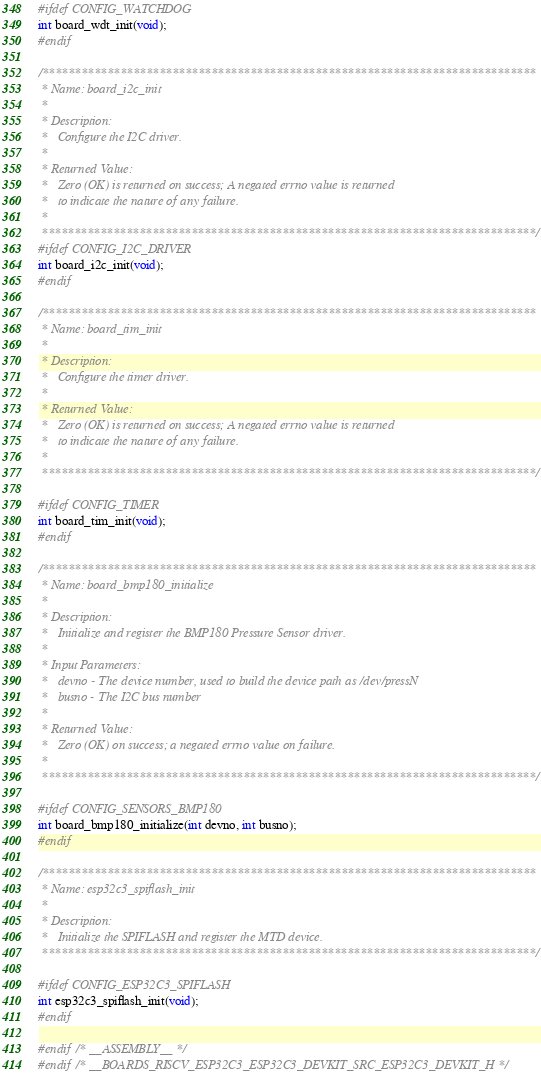<code> <loc_0><loc_0><loc_500><loc_500><_C_>
#ifdef CONFIG_WATCHDOG
int board_wdt_init(void);
#endif

/****************************************************************************
 * Name: board_i2c_init
 *
 * Description:
 *   Configure the I2C driver.
 *
 * Returned Value:
 *   Zero (OK) is returned on success; A negated errno value is returned
 *   to indicate the nature of any failure.
 *
 ****************************************************************************/
#ifdef CONFIG_I2C_DRIVER
int board_i2c_init(void);
#endif

/****************************************************************************
 * Name: board_tim_init
 *
 * Description:
 *   Configure the timer driver.
 *
 * Returned Value:
 *   Zero (OK) is returned on success; A negated errno value is returned
 *   to indicate the nature of any failure.
 *
 ****************************************************************************/

#ifdef CONFIG_TIMER
int board_tim_init(void);
#endif

/****************************************************************************
 * Name: board_bmp180_initialize
 *
 * Description:
 *   Initialize and register the BMP180 Pressure Sensor driver.
 *
 * Input Parameters:
 *   devno - The device number, used to build the device path as /dev/pressN
 *   busno - The I2C bus number
 *
 * Returned Value:
 *   Zero (OK) on success; a negated errno value on failure.
 *
 ****************************************************************************/

#ifdef CONFIG_SENSORS_BMP180
int board_bmp180_initialize(int devno, int busno);
#endif

/****************************************************************************
 * Name: esp32c3_spiflash_init
 *
 * Description:
 *   Initialize the SPIFLASH and register the MTD device.
 ****************************************************************************/

#ifdef CONFIG_ESP32C3_SPIFLASH
int esp32c3_spiflash_init(void);
#endif

#endif /* __ASSEMBLY__ */
#endif /* __BOARDS_RISCV_ESP32C3_ESP32C3_DEVKIT_SRC_ESP32C3_DEVKIT_H */
</code> 